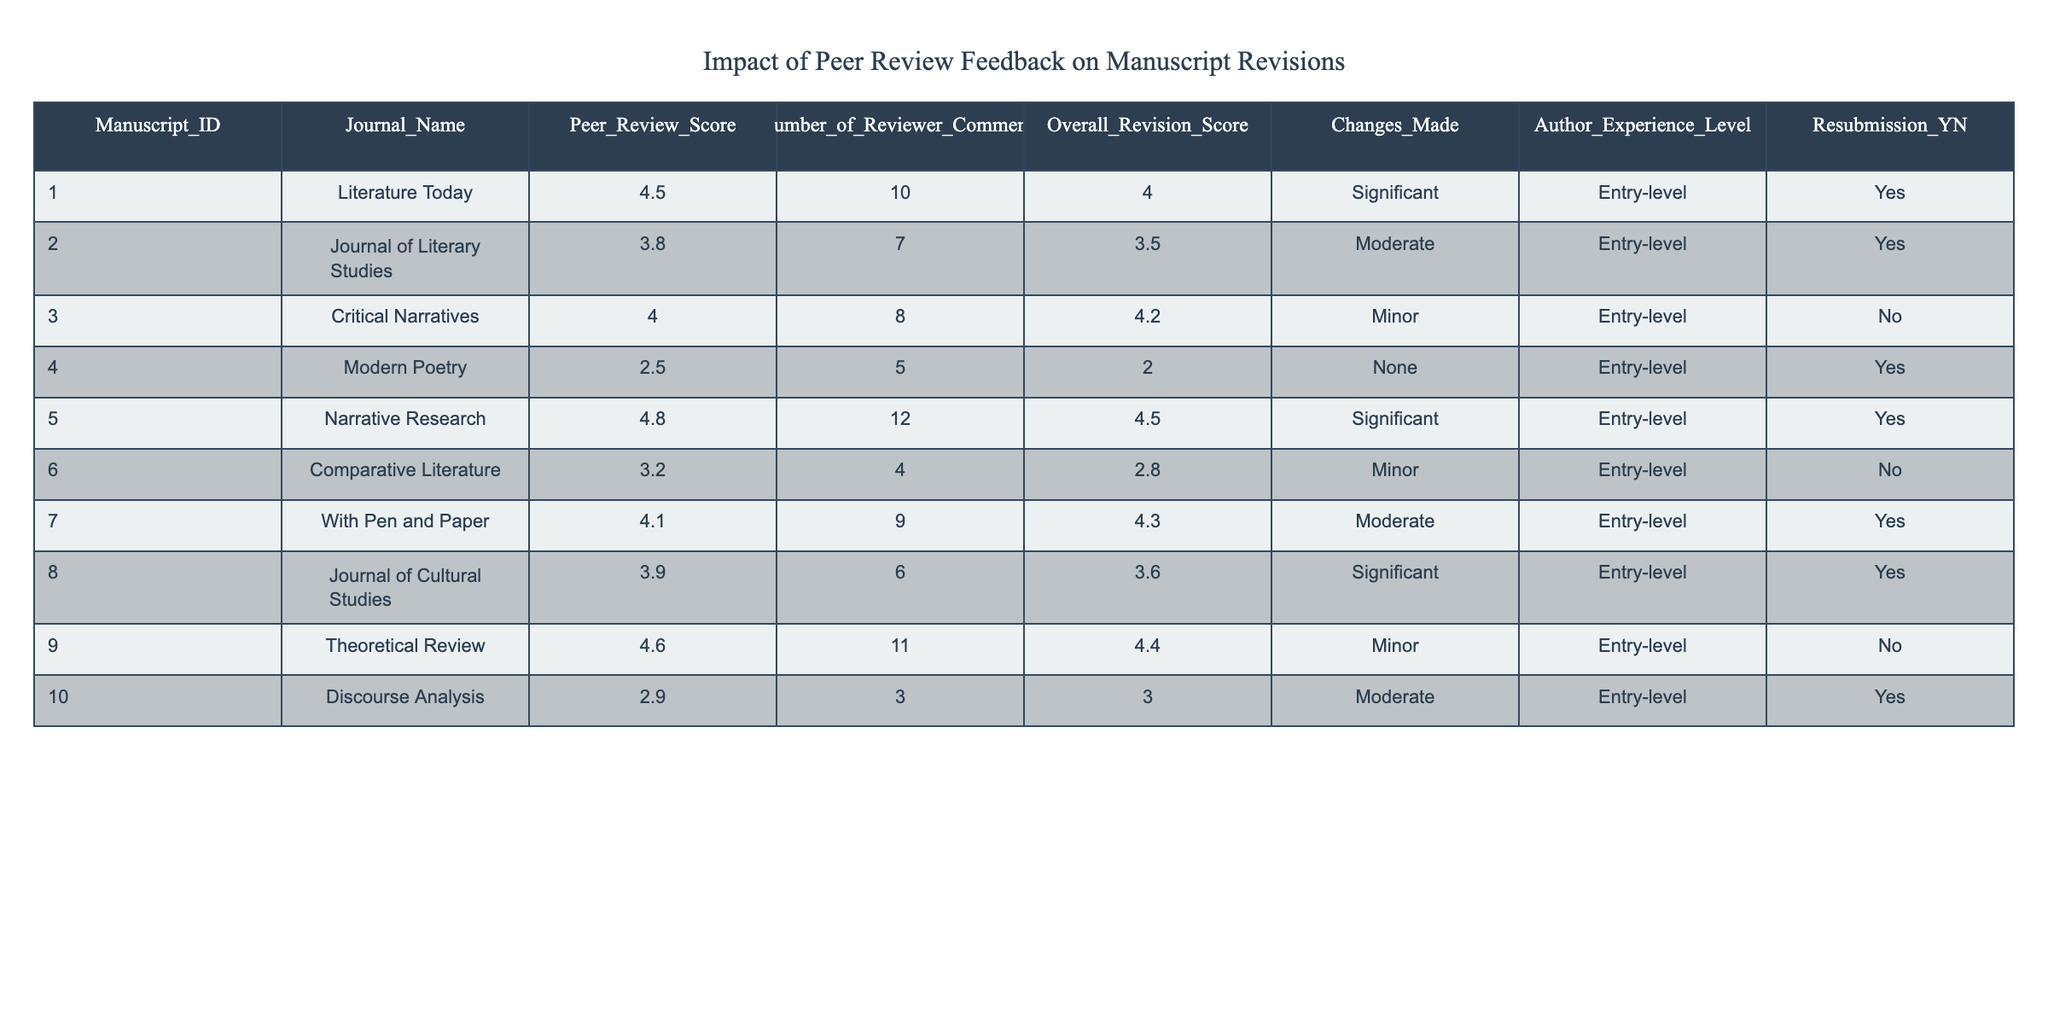What is the highest Peer Review Score listed in the table? The Peer Review Score column has several values. Scanning through the column, we see the highest value is 4.8 from the manuscript ID 005.
Answer: 4.8 How many manuscripts received a Significant change designation? Looking at the Changes Made column, we count the number of entries marked as "Significant." These are for manuscript IDs 001, 005, 008, which gives us a total of 3.
Answer: 3 What is the average Overall Revision Score for manuscripts that were resubmitted? We filter the table to only include manuscripts where Resubmission is "Yes," which includes IDs 001, 002, 005, 007, 008, and 010. Their Overall Revision Scores are 4.0, 3.5, 4.5, 4.3, 3.6, and 3.0. Adding them gives 24.0, and dividing by 6 gives an average of 4.0.
Answer: 4.0 Did any manuscripts submitted to "Modern Poetry" receive a positive Peer Review Score? Manuscipt ID 004, submitted to "Modern Poetry," has a Peer Review Score of 2.5, which is not a positive score. Hence, the answer is no.
Answer: No Which manuscript had the highest number of reviewer comments and what was its Overall Revision Score? Scanning the Number of Reviewer Comments column, manuscript ID 005 has the highest number with 12 comments. Its Overall Revision Score is 4.5.
Answer: 4.5 How many manuscripts were submitted by Entry-level authors that had a Moderate change designation? Looking at the Changes Made column for Entry-level authors, we see that manuscript IDs 002, 007, and 010 received a Moderate designation. Summing these gives a total of 3 manuscripts.
Answer: 3 Which manuscripts did not receive any changes according to the Changes Made column? Evaluating the Changes Made column, the only manuscript that shows "None" is ID 004 from "Modern Poetry."
Answer: 1 (manuscript ID 004) What is the difference between the highest and lowest Overall Revision Scores? The highest Overall Revision Score is 4.5 from manuscript ID 005, while the lowest is 2.0 from manuscript ID 004. The difference is 4.5 - 2.0 = 2.5.
Answer: 2.5 How many manuscripts received a Peer Review Score of 4.0 or higher? Reviewing the Peer Review Score column, the manuscripts with scores of 4.0 or higher are IDs 001, 003, 005, 007, 009, and 010. Counting these gives us a total of 6 manuscripts.
Answer: 6 